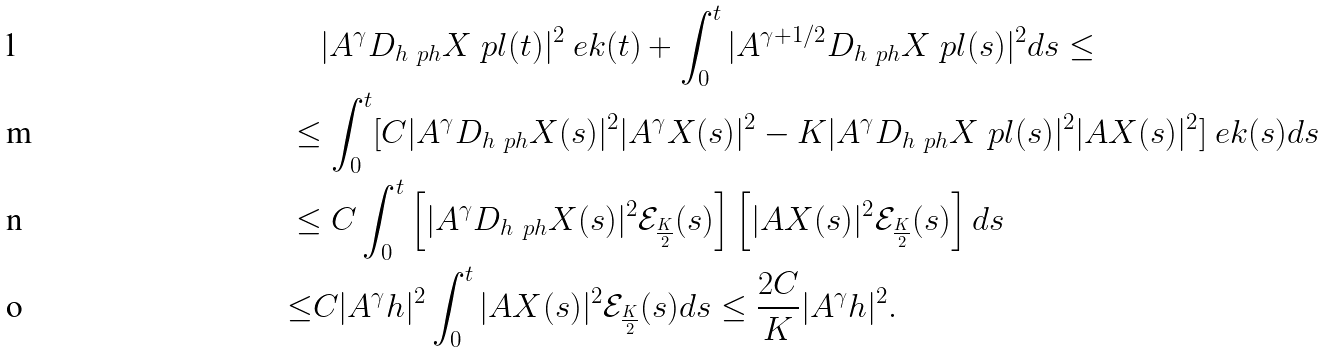<formula> <loc_0><loc_0><loc_500><loc_500>& \quad | A ^ { \gamma } D _ { h ^ { \ } p h } X ^ { \ } p l ( t ) | ^ { 2 } \ e k ( t ) + \int _ { 0 } ^ { t } | A ^ { \gamma + 1 / 2 } D _ { h ^ { \ } p h } X ^ { \ } p l ( s ) | ^ { 2 } d s \leq \\ & \leq \int _ { 0 } ^ { t } [ C | A ^ { \gamma } D _ { h ^ { \ } p h } X ( s ) | ^ { 2 } | A ^ { \gamma } X ( s ) | ^ { 2 } - K | A ^ { \gamma } D _ { h ^ { \ } p h } X ^ { \ } p l ( s ) | ^ { 2 } | A X ( s ) | ^ { 2 } ] \ e k ( s ) d s \\ & \leq C \int _ { 0 } ^ { t } \left [ | A ^ { \gamma } D _ { h ^ { \ } p h } X ( s ) | ^ { 2 } \mathcal { E } _ { \frac { K } { 2 } } ( s ) \right ] \left [ | A X ( s ) | ^ { 2 } \mathcal { E } _ { \frac { K } { 2 } } ( s ) \right ] d s \\ & { \leq } C | A ^ { \gamma } h | ^ { 2 } \int _ { 0 } ^ { t } | A X ( s ) | ^ { 2 } \mathcal { E } _ { \frac { K } { 2 } } ( s ) d s \leq \frac { 2 C } K | A ^ { \gamma } h | ^ { 2 } .</formula> 